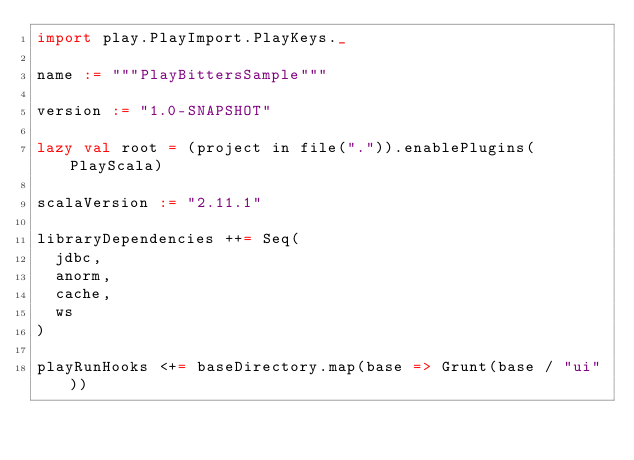<code> <loc_0><loc_0><loc_500><loc_500><_Scala_>import play.PlayImport.PlayKeys._

name := """PlayBittersSample"""

version := "1.0-SNAPSHOT"

lazy val root = (project in file(".")).enablePlugins(PlayScala)

scalaVersion := "2.11.1"

libraryDependencies ++= Seq(
  jdbc,
  anorm,
  cache,
  ws
)

playRunHooks <+= baseDirectory.map(base => Grunt(base / "ui"))</code> 